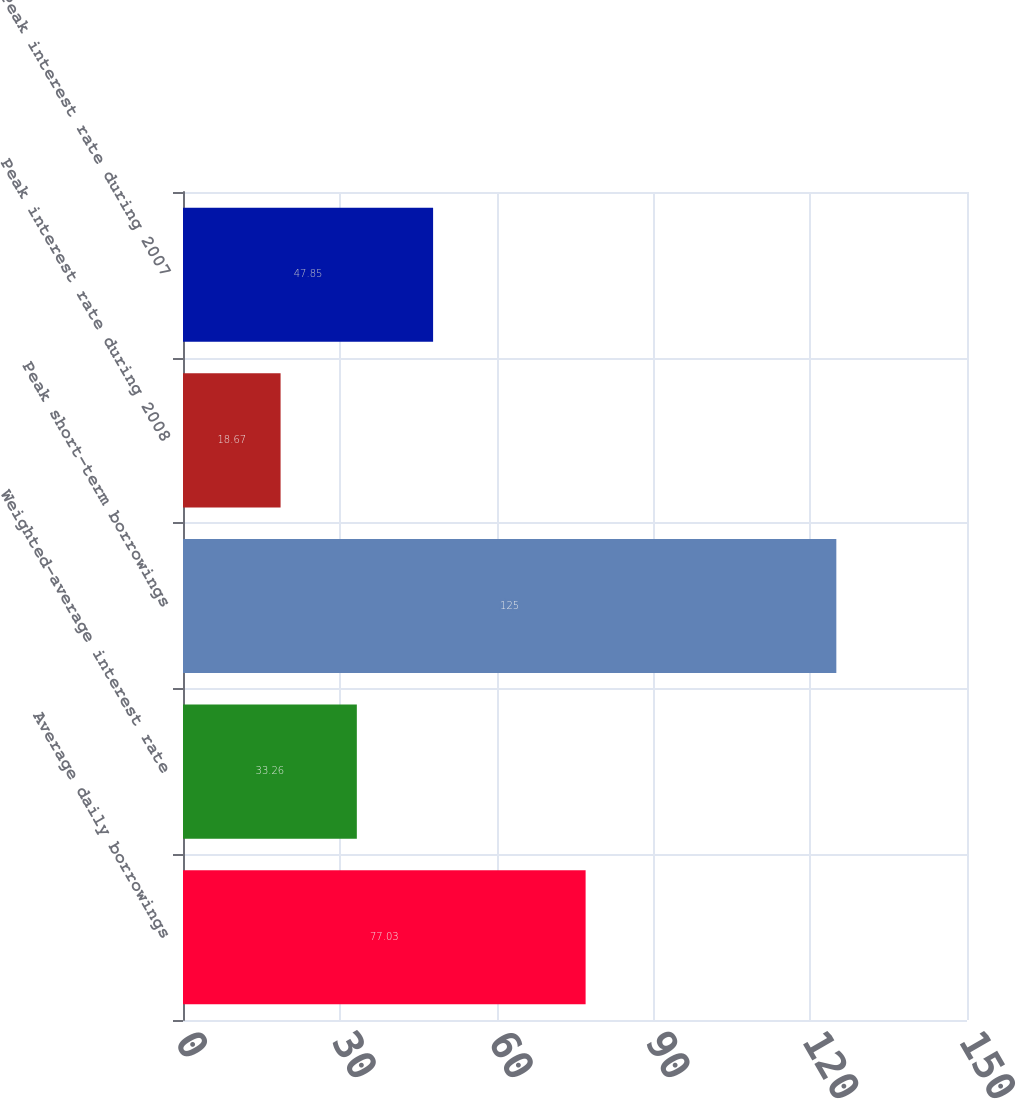Convert chart to OTSL. <chart><loc_0><loc_0><loc_500><loc_500><bar_chart><fcel>Average daily borrowings<fcel>Weighted-average interest rate<fcel>Peak short-term borrowings<fcel>Peak interest rate during 2008<fcel>Peak interest rate during 2007<nl><fcel>77.03<fcel>33.26<fcel>125<fcel>18.67<fcel>47.85<nl></chart> 